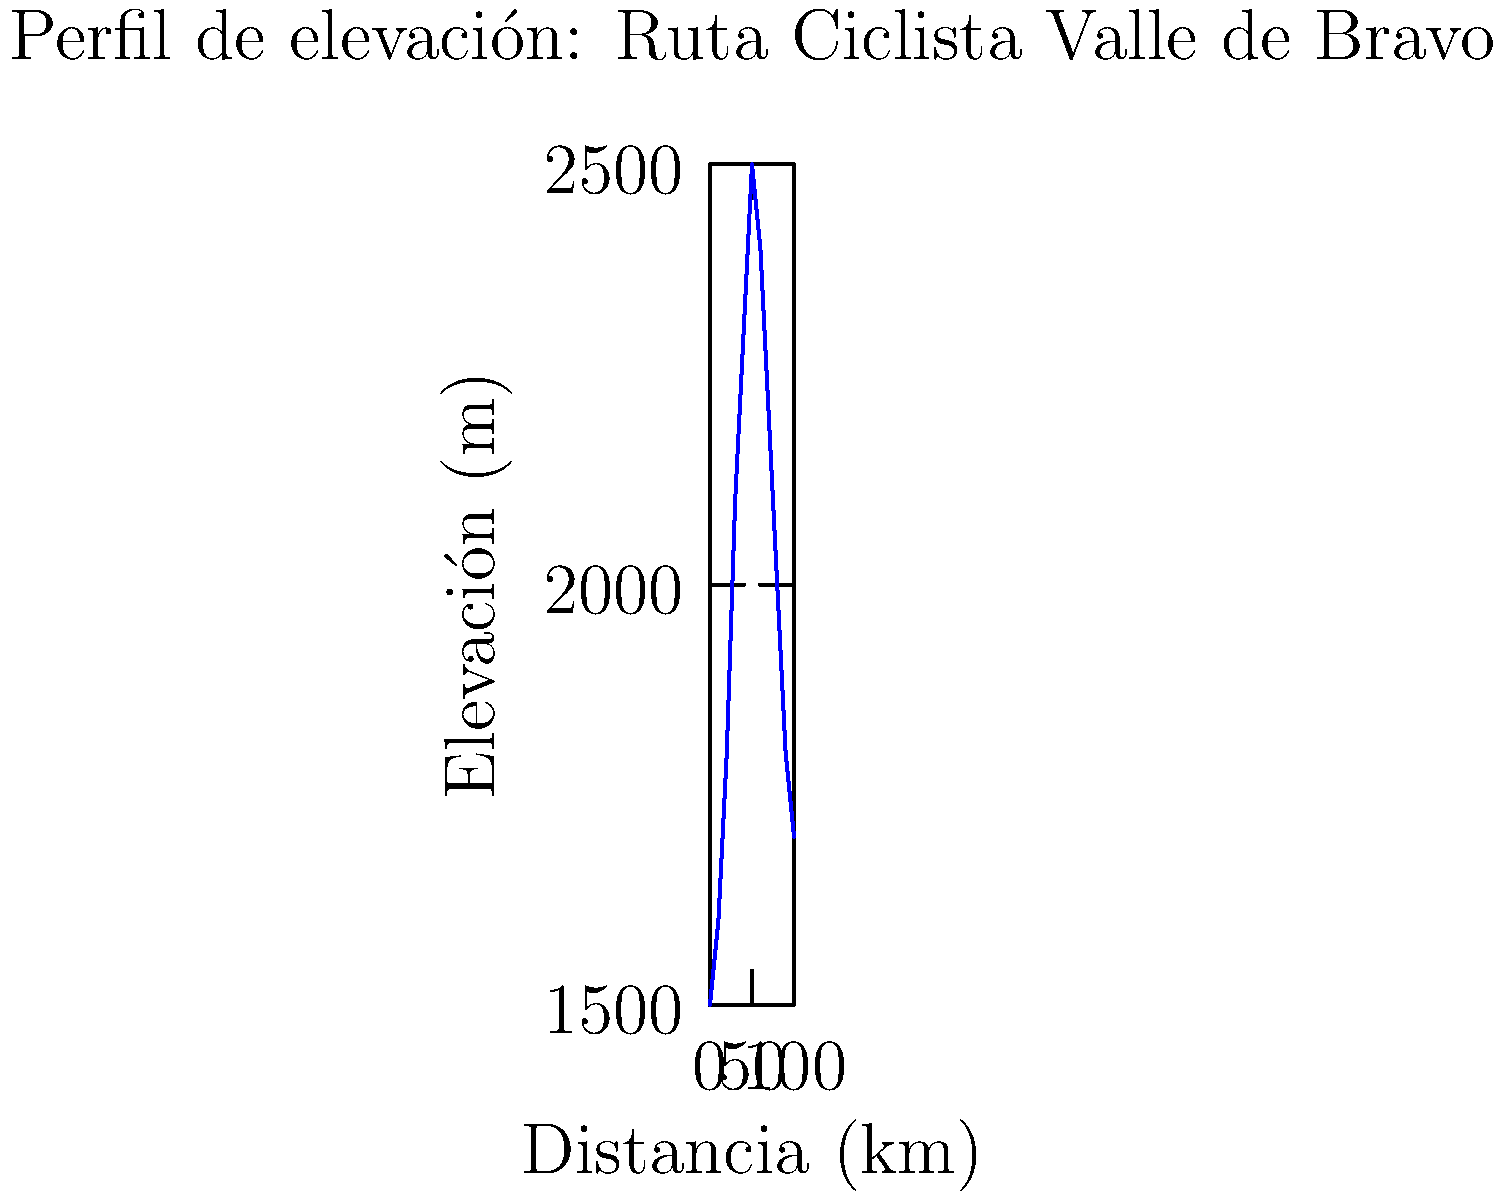El gráfico muestra el perfil de elevación de una popular ruta ciclista en Valle de Bravo, México. ¿Cuál es la diferencia de elevación aproximada entre el punto más bajo y el punto más alto de la ruta? Para encontrar la diferencia de elevación entre el punto más bajo y el más alto, seguimos estos pasos:

1. Identificar el punto más bajo:
   Observando el gráfico, el punto más bajo está al inicio de la ruta, a una elevación de aproximadamente 1500 m.

2. Identificar el punto más alto:
   El punto más alto se encuentra aproximadamente a 50 km del inicio, con una elevación de cerca de 2500 m.

3. Calcular la diferencia:
   $\text{Diferencia} = \text{Punto más alto} - \text{Punto más bajo}$
   $\text{Diferencia} \approx 2500 \text{ m} - 1500 \text{ m} = 1000 \text{ m}$

Por lo tanto, la diferencia de elevación aproximada entre el punto más bajo y el más alto es de 1000 metros.
Answer: 1000 m 